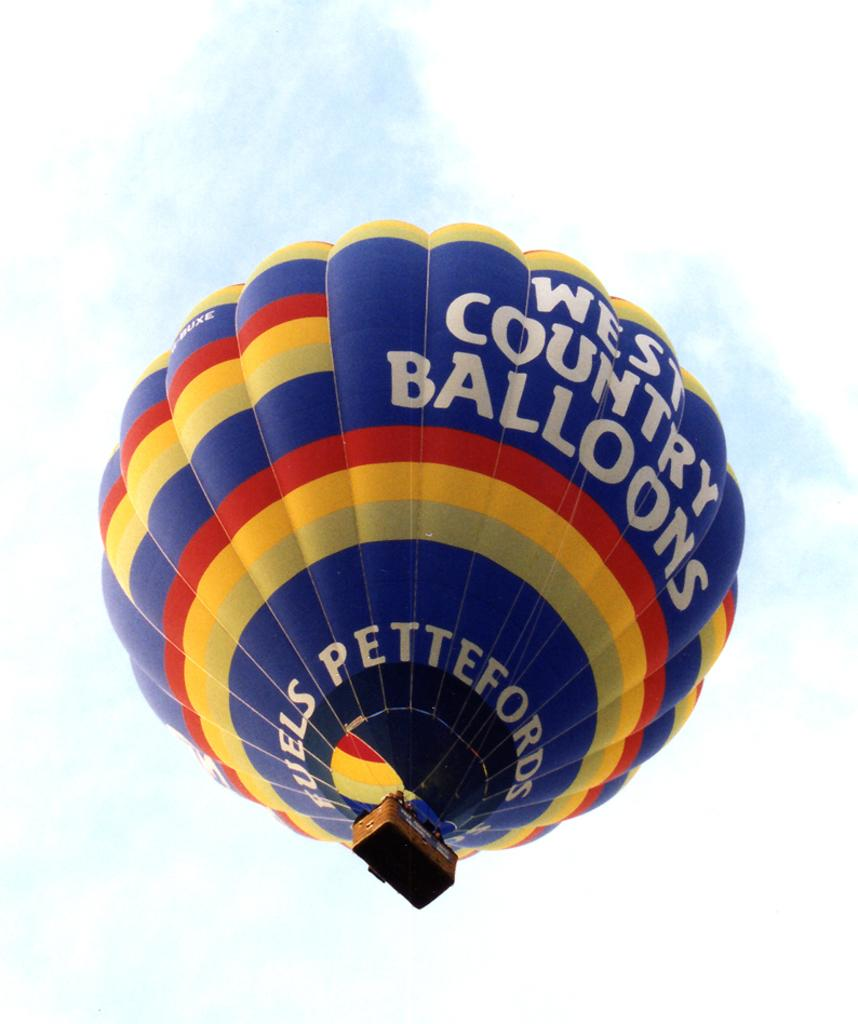What is the main subject of the image? The main subject of the image is a big air balloon. What colors can be seen on the air balloon? The air balloon has blue, red, and yellow colors. What is visible at the top of the image? The sky is visible at the top of the image. Can you tell me how many corks are attached to the air balloon in the image? There is no mention of corks in the image, so it is impossible to determine how many corks are attached to the air balloon. 